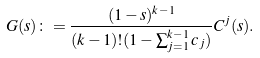Convert formula to latex. <formula><loc_0><loc_0><loc_500><loc_500>G ( s ) \colon = \frac { ( 1 - s ) ^ { k - 1 } } { ( k - 1 ) ! ( 1 - \sum _ { j = 1 } ^ { k - 1 } c _ { j } ) } C ^ { j } ( s ) .</formula> 